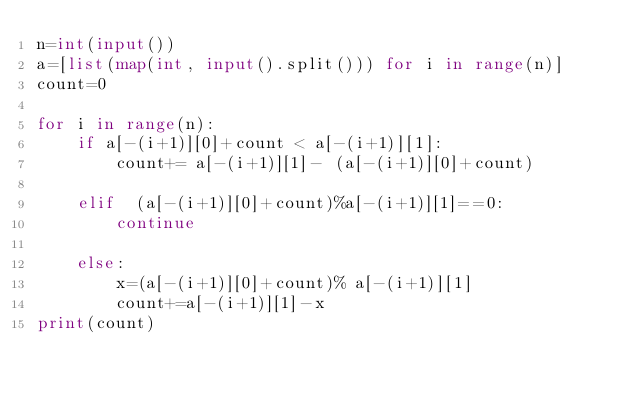<code> <loc_0><loc_0><loc_500><loc_500><_Python_>n=int(input())
a=[list(map(int, input().split())) for i in range(n)]
count=0

for i in range(n):
    if a[-(i+1)][0]+count < a[-(i+1)][1]:
        count+= a[-(i+1)][1]- (a[-(i+1)][0]+count)

    elif  (a[-(i+1)][0]+count)%a[-(i+1)][1]==0:
        continue

    else:
        x=(a[-(i+1)][0]+count)% a[-(i+1)][1]
        count+=a[-(i+1)][1]-x
print(count)</code> 